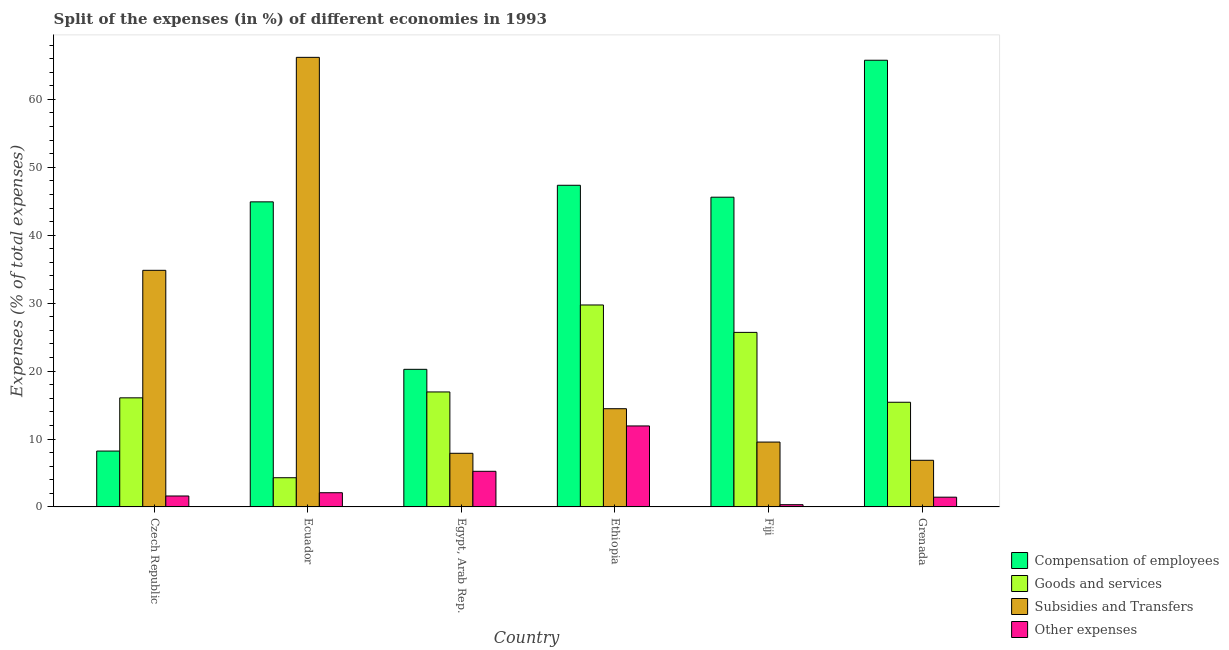How many different coloured bars are there?
Give a very brief answer. 4. Are the number of bars per tick equal to the number of legend labels?
Give a very brief answer. Yes. How many bars are there on the 3rd tick from the left?
Offer a very short reply. 4. How many bars are there on the 4th tick from the right?
Provide a short and direct response. 4. What is the label of the 4th group of bars from the left?
Your response must be concise. Ethiopia. In how many cases, is the number of bars for a given country not equal to the number of legend labels?
Offer a very short reply. 0. What is the percentage of amount spent on other expenses in Ethiopia?
Your answer should be very brief. 11.92. Across all countries, what is the maximum percentage of amount spent on compensation of employees?
Make the answer very short. 65.76. Across all countries, what is the minimum percentage of amount spent on other expenses?
Provide a short and direct response. 0.33. In which country was the percentage of amount spent on subsidies maximum?
Provide a succinct answer. Ecuador. In which country was the percentage of amount spent on compensation of employees minimum?
Provide a short and direct response. Czech Republic. What is the total percentage of amount spent on subsidies in the graph?
Your answer should be compact. 139.8. What is the difference between the percentage of amount spent on goods and services in Czech Republic and that in Ethiopia?
Give a very brief answer. -13.67. What is the difference between the percentage of amount spent on subsidies in Fiji and the percentage of amount spent on goods and services in Grenada?
Offer a terse response. -5.86. What is the average percentage of amount spent on other expenses per country?
Your answer should be compact. 3.77. What is the difference between the percentage of amount spent on other expenses and percentage of amount spent on subsidies in Ecuador?
Your answer should be compact. -64.1. What is the ratio of the percentage of amount spent on subsidies in Ecuador to that in Ethiopia?
Your response must be concise. 4.58. Is the percentage of amount spent on compensation of employees in Ecuador less than that in Ethiopia?
Ensure brevity in your answer.  Yes. Is the difference between the percentage of amount spent on other expenses in Ecuador and Grenada greater than the difference between the percentage of amount spent on subsidies in Ecuador and Grenada?
Give a very brief answer. No. What is the difference between the highest and the second highest percentage of amount spent on compensation of employees?
Provide a short and direct response. 18.41. What is the difference between the highest and the lowest percentage of amount spent on subsidies?
Offer a very short reply. 59.32. In how many countries, is the percentage of amount spent on goods and services greater than the average percentage of amount spent on goods and services taken over all countries?
Your response must be concise. 2. Is the sum of the percentage of amount spent on compensation of employees in Ecuador and Egypt, Arab Rep. greater than the maximum percentage of amount spent on subsidies across all countries?
Keep it short and to the point. No. Is it the case that in every country, the sum of the percentage of amount spent on compensation of employees and percentage of amount spent on other expenses is greater than the sum of percentage of amount spent on goods and services and percentage of amount spent on subsidies?
Your response must be concise. No. What does the 2nd bar from the left in Ethiopia represents?
Make the answer very short. Goods and services. What does the 1st bar from the right in Grenada represents?
Offer a very short reply. Other expenses. Are all the bars in the graph horizontal?
Your response must be concise. No. What is the difference between two consecutive major ticks on the Y-axis?
Give a very brief answer. 10. Does the graph contain any zero values?
Offer a very short reply. No. Does the graph contain grids?
Your answer should be very brief. No. What is the title of the graph?
Provide a short and direct response. Split of the expenses (in %) of different economies in 1993. Does "Ease of arranging shipments" appear as one of the legend labels in the graph?
Offer a terse response. No. What is the label or title of the X-axis?
Offer a terse response. Country. What is the label or title of the Y-axis?
Keep it short and to the point. Expenses (% of total expenses). What is the Expenses (% of total expenses) in Compensation of employees in Czech Republic?
Make the answer very short. 8.23. What is the Expenses (% of total expenses) in Goods and services in Czech Republic?
Make the answer very short. 16.06. What is the Expenses (% of total expenses) of Subsidies and Transfers in Czech Republic?
Give a very brief answer. 34.84. What is the Expenses (% of total expenses) of Other expenses in Czech Republic?
Your answer should be compact. 1.61. What is the Expenses (% of total expenses) of Compensation of employees in Ecuador?
Give a very brief answer. 44.92. What is the Expenses (% of total expenses) in Goods and services in Ecuador?
Your response must be concise. 4.3. What is the Expenses (% of total expenses) of Subsidies and Transfers in Ecuador?
Give a very brief answer. 66.19. What is the Expenses (% of total expenses) in Other expenses in Ecuador?
Give a very brief answer. 2.09. What is the Expenses (% of total expenses) in Compensation of employees in Egypt, Arab Rep.?
Offer a very short reply. 20.26. What is the Expenses (% of total expenses) in Goods and services in Egypt, Arab Rep.?
Your answer should be compact. 16.93. What is the Expenses (% of total expenses) of Subsidies and Transfers in Egypt, Arab Rep.?
Offer a very short reply. 7.9. What is the Expenses (% of total expenses) in Other expenses in Egypt, Arab Rep.?
Make the answer very short. 5.24. What is the Expenses (% of total expenses) in Compensation of employees in Ethiopia?
Your answer should be very brief. 47.36. What is the Expenses (% of total expenses) in Goods and services in Ethiopia?
Keep it short and to the point. 29.73. What is the Expenses (% of total expenses) in Subsidies and Transfers in Ethiopia?
Your answer should be compact. 14.46. What is the Expenses (% of total expenses) of Other expenses in Ethiopia?
Ensure brevity in your answer.  11.92. What is the Expenses (% of total expenses) in Compensation of employees in Fiji?
Offer a terse response. 45.6. What is the Expenses (% of total expenses) of Goods and services in Fiji?
Make the answer very short. 25.7. What is the Expenses (% of total expenses) of Subsidies and Transfers in Fiji?
Provide a succinct answer. 9.55. What is the Expenses (% of total expenses) of Other expenses in Fiji?
Your answer should be compact. 0.33. What is the Expenses (% of total expenses) in Compensation of employees in Grenada?
Provide a succinct answer. 65.76. What is the Expenses (% of total expenses) of Goods and services in Grenada?
Offer a very short reply. 15.41. What is the Expenses (% of total expenses) of Subsidies and Transfers in Grenada?
Provide a short and direct response. 6.87. What is the Expenses (% of total expenses) of Other expenses in Grenada?
Provide a short and direct response. 1.43. Across all countries, what is the maximum Expenses (% of total expenses) in Compensation of employees?
Keep it short and to the point. 65.76. Across all countries, what is the maximum Expenses (% of total expenses) of Goods and services?
Your answer should be very brief. 29.73. Across all countries, what is the maximum Expenses (% of total expenses) in Subsidies and Transfers?
Provide a succinct answer. 66.19. Across all countries, what is the maximum Expenses (% of total expenses) in Other expenses?
Give a very brief answer. 11.92. Across all countries, what is the minimum Expenses (% of total expenses) of Compensation of employees?
Provide a succinct answer. 8.23. Across all countries, what is the minimum Expenses (% of total expenses) in Goods and services?
Your answer should be compact. 4.3. Across all countries, what is the minimum Expenses (% of total expenses) in Subsidies and Transfers?
Ensure brevity in your answer.  6.87. Across all countries, what is the minimum Expenses (% of total expenses) of Other expenses?
Make the answer very short. 0.33. What is the total Expenses (% of total expenses) of Compensation of employees in the graph?
Ensure brevity in your answer.  232.13. What is the total Expenses (% of total expenses) of Goods and services in the graph?
Your answer should be very brief. 108.13. What is the total Expenses (% of total expenses) of Subsidies and Transfers in the graph?
Provide a short and direct response. 139.8. What is the total Expenses (% of total expenses) in Other expenses in the graph?
Provide a short and direct response. 22.63. What is the difference between the Expenses (% of total expenses) in Compensation of employees in Czech Republic and that in Ecuador?
Offer a very short reply. -36.69. What is the difference between the Expenses (% of total expenses) of Goods and services in Czech Republic and that in Ecuador?
Provide a short and direct response. 11.76. What is the difference between the Expenses (% of total expenses) of Subsidies and Transfers in Czech Republic and that in Ecuador?
Provide a short and direct response. -31.36. What is the difference between the Expenses (% of total expenses) in Other expenses in Czech Republic and that in Ecuador?
Provide a short and direct response. -0.48. What is the difference between the Expenses (% of total expenses) of Compensation of employees in Czech Republic and that in Egypt, Arab Rep.?
Make the answer very short. -12.03. What is the difference between the Expenses (% of total expenses) in Goods and services in Czech Republic and that in Egypt, Arab Rep.?
Your answer should be compact. -0.87. What is the difference between the Expenses (% of total expenses) of Subsidies and Transfers in Czech Republic and that in Egypt, Arab Rep.?
Provide a short and direct response. 26.94. What is the difference between the Expenses (% of total expenses) of Other expenses in Czech Republic and that in Egypt, Arab Rep.?
Ensure brevity in your answer.  -3.63. What is the difference between the Expenses (% of total expenses) of Compensation of employees in Czech Republic and that in Ethiopia?
Your response must be concise. -39.13. What is the difference between the Expenses (% of total expenses) in Goods and services in Czech Republic and that in Ethiopia?
Provide a succinct answer. -13.67. What is the difference between the Expenses (% of total expenses) of Subsidies and Transfers in Czech Republic and that in Ethiopia?
Provide a short and direct response. 20.37. What is the difference between the Expenses (% of total expenses) of Other expenses in Czech Republic and that in Ethiopia?
Your response must be concise. -10.31. What is the difference between the Expenses (% of total expenses) in Compensation of employees in Czech Republic and that in Fiji?
Give a very brief answer. -37.38. What is the difference between the Expenses (% of total expenses) in Goods and services in Czech Republic and that in Fiji?
Offer a terse response. -9.64. What is the difference between the Expenses (% of total expenses) of Subsidies and Transfers in Czech Republic and that in Fiji?
Offer a very short reply. 25.29. What is the difference between the Expenses (% of total expenses) of Other expenses in Czech Republic and that in Fiji?
Offer a terse response. 1.28. What is the difference between the Expenses (% of total expenses) in Compensation of employees in Czech Republic and that in Grenada?
Offer a very short reply. -57.54. What is the difference between the Expenses (% of total expenses) of Goods and services in Czech Republic and that in Grenada?
Make the answer very short. 0.65. What is the difference between the Expenses (% of total expenses) of Subsidies and Transfers in Czech Republic and that in Grenada?
Offer a terse response. 27.97. What is the difference between the Expenses (% of total expenses) in Other expenses in Czech Republic and that in Grenada?
Offer a very short reply. 0.18. What is the difference between the Expenses (% of total expenses) of Compensation of employees in Ecuador and that in Egypt, Arab Rep.?
Ensure brevity in your answer.  24.66. What is the difference between the Expenses (% of total expenses) in Goods and services in Ecuador and that in Egypt, Arab Rep.?
Provide a succinct answer. -12.63. What is the difference between the Expenses (% of total expenses) in Subsidies and Transfers in Ecuador and that in Egypt, Arab Rep.?
Your answer should be compact. 58.29. What is the difference between the Expenses (% of total expenses) of Other expenses in Ecuador and that in Egypt, Arab Rep.?
Offer a very short reply. -3.15. What is the difference between the Expenses (% of total expenses) of Compensation of employees in Ecuador and that in Ethiopia?
Your answer should be compact. -2.44. What is the difference between the Expenses (% of total expenses) in Goods and services in Ecuador and that in Ethiopia?
Ensure brevity in your answer.  -25.43. What is the difference between the Expenses (% of total expenses) of Subsidies and Transfers in Ecuador and that in Ethiopia?
Give a very brief answer. 51.73. What is the difference between the Expenses (% of total expenses) in Other expenses in Ecuador and that in Ethiopia?
Give a very brief answer. -9.83. What is the difference between the Expenses (% of total expenses) in Compensation of employees in Ecuador and that in Fiji?
Your answer should be very brief. -0.69. What is the difference between the Expenses (% of total expenses) in Goods and services in Ecuador and that in Fiji?
Your answer should be very brief. -21.4. What is the difference between the Expenses (% of total expenses) of Subsidies and Transfers in Ecuador and that in Fiji?
Ensure brevity in your answer.  56.64. What is the difference between the Expenses (% of total expenses) of Other expenses in Ecuador and that in Fiji?
Keep it short and to the point. 1.76. What is the difference between the Expenses (% of total expenses) in Compensation of employees in Ecuador and that in Grenada?
Your response must be concise. -20.85. What is the difference between the Expenses (% of total expenses) of Goods and services in Ecuador and that in Grenada?
Offer a terse response. -11.11. What is the difference between the Expenses (% of total expenses) of Subsidies and Transfers in Ecuador and that in Grenada?
Your answer should be very brief. 59.32. What is the difference between the Expenses (% of total expenses) of Other expenses in Ecuador and that in Grenada?
Your answer should be compact. 0.66. What is the difference between the Expenses (% of total expenses) of Compensation of employees in Egypt, Arab Rep. and that in Ethiopia?
Provide a short and direct response. -27.1. What is the difference between the Expenses (% of total expenses) in Goods and services in Egypt, Arab Rep. and that in Ethiopia?
Ensure brevity in your answer.  -12.8. What is the difference between the Expenses (% of total expenses) of Subsidies and Transfers in Egypt, Arab Rep. and that in Ethiopia?
Your answer should be compact. -6.56. What is the difference between the Expenses (% of total expenses) of Other expenses in Egypt, Arab Rep. and that in Ethiopia?
Provide a short and direct response. -6.68. What is the difference between the Expenses (% of total expenses) of Compensation of employees in Egypt, Arab Rep. and that in Fiji?
Ensure brevity in your answer.  -25.34. What is the difference between the Expenses (% of total expenses) in Goods and services in Egypt, Arab Rep. and that in Fiji?
Offer a terse response. -8.77. What is the difference between the Expenses (% of total expenses) in Subsidies and Transfers in Egypt, Arab Rep. and that in Fiji?
Ensure brevity in your answer.  -1.65. What is the difference between the Expenses (% of total expenses) in Other expenses in Egypt, Arab Rep. and that in Fiji?
Give a very brief answer. 4.92. What is the difference between the Expenses (% of total expenses) in Compensation of employees in Egypt, Arab Rep. and that in Grenada?
Keep it short and to the point. -45.5. What is the difference between the Expenses (% of total expenses) of Goods and services in Egypt, Arab Rep. and that in Grenada?
Make the answer very short. 1.52. What is the difference between the Expenses (% of total expenses) of Subsidies and Transfers in Egypt, Arab Rep. and that in Grenada?
Your response must be concise. 1.03. What is the difference between the Expenses (% of total expenses) of Other expenses in Egypt, Arab Rep. and that in Grenada?
Offer a very short reply. 3.81. What is the difference between the Expenses (% of total expenses) of Compensation of employees in Ethiopia and that in Fiji?
Your answer should be compact. 1.76. What is the difference between the Expenses (% of total expenses) of Goods and services in Ethiopia and that in Fiji?
Offer a very short reply. 4.04. What is the difference between the Expenses (% of total expenses) of Subsidies and Transfers in Ethiopia and that in Fiji?
Offer a terse response. 4.91. What is the difference between the Expenses (% of total expenses) in Other expenses in Ethiopia and that in Fiji?
Your answer should be very brief. 11.59. What is the difference between the Expenses (% of total expenses) of Compensation of employees in Ethiopia and that in Grenada?
Provide a succinct answer. -18.41. What is the difference between the Expenses (% of total expenses) in Goods and services in Ethiopia and that in Grenada?
Your response must be concise. 14.32. What is the difference between the Expenses (% of total expenses) of Subsidies and Transfers in Ethiopia and that in Grenada?
Make the answer very short. 7.6. What is the difference between the Expenses (% of total expenses) of Other expenses in Ethiopia and that in Grenada?
Provide a succinct answer. 10.49. What is the difference between the Expenses (% of total expenses) of Compensation of employees in Fiji and that in Grenada?
Offer a very short reply. -20.16. What is the difference between the Expenses (% of total expenses) in Goods and services in Fiji and that in Grenada?
Offer a very short reply. 10.29. What is the difference between the Expenses (% of total expenses) in Subsidies and Transfers in Fiji and that in Grenada?
Offer a very short reply. 2.68. What is the difference between the Expenses (% of total expenses) in Other expenses in Fiji and that in Grenada?
Give a very brief answer. -1.11. What is the difference between the Expenses (% of total expenses) of Compensation of employees in Czech Republic and the Expenses (% of total expenses) of Goods and services in Ecuador?
Provide a succinct answer. 3.93. What is the difference between the Expenses (% of total expenses) in Compensation of employees in Czech Republic and the Expenses (% of total expenses) in Subsidies and Transfers in Ecuador?
Your answer should be very brief. -57.96. What is the difference between the Expenses (% of total expenses) in Compensation of employees in Czech Republic and the Expenses (% of total expenses) in Other expenses in Ecuador?
Make the answer very short. 6.14. What is the difference between the Expenses (% of total expenses) in Goods and services in Czech Republic and the Expenses (% of total expenses) in Subsidies and Transfers in Ecuador?
Your response must be concise. -50.13. What is the difference between the Expenses (% of total expenses) of Goods and services in Czech Republic and the Expenses (% of total expenses) of Other expenses in Ecuador?
Your answer should be very brief. 13.97. What is the difference between the Expenses (% of total expenses) of Subsidies and Transfers in Czech Republic and the Expenses (% of total expenses) of Other expenses in Ecuador?
Give a very brief answer. 32.74. What is the difference between the Expenses (% of total expenses) of Compensation of employees in Czech Republic and the Expenses (% of total expenses) of Goods and services in Egypt, Arab Rep.?
Your response must be concise. -8.7. What is the difference between the Expenses (% of total expenses) in Compensation of employees in Czech Republic and the Expenses (% of total expenses) in Subsidies and Transfers in Egypt, Arab Rep.?
Keep it short and to the point. 0.33. What is the difference between the Expenses (% of total expenses) of Compensation of employees in Czech Republic and the Expenses (% of total expenses) of Other expenses in Egypt, Arab Rep.?
Your answer should be compact. 2.98. What is the difference between the Expenses (% of total expenses) in Goods and services in Czech Republic and the Expenses (% of total expenses) in Subsidies and Transfers in Egypt, Arab Rep.?
Ensure brevity in your answer.  8.16. What is the difference between the Expenses (% of total expenses) in Goods and services in Czech Republic and the Expenses (% of total expenses) in Other expenses in Egypt, Arab Rep.?
Keep it short and to the point. 10.82. What is the difference between the Expenses (% of total expenses) of Subsidies and Transfers in Czech Republic and the Expenses (% of total expenses) of Other expenses in Egypt, Arab Rep.?
Keep it short and to the point. 29.59. What is the difference between the Expenses (% of total expenses) in Compensation of employees in Czech Republic and the Expenses (% of total expenses) in Goods and services in Ethiopia?
Your answer should be compact. -21.51. What is the difference between the Expenses (% of total expenses) in Compensation of employees in Czech Republic and the Expenses (% of total expenses) in Subsidies and Transfers in Ethiopia?
Your response must be concise. -6.23. What is the difference between the Expenses (% of total expenses) in Compensation of employees in Czech Republic and the Expenses (% of total expenses) in Other expenses in Ethiopia?
Offer a terse response. -3.7. What is the difference between the Expenses (% of total expenses) in Goods and services in Czech Republic and the Expenses (% of total expenses) in Subsidies and Transfers in Ethiopia?
Ensure brevity in your answer.  1.6. What is the difference between the Expenses (% of total expenses) in Goods and services in Czech Republic and the Expenses (% of total expenses) in Other expenses in Ethiopia?
Provide a short and direct response. 4.14. What is the difference between the Expenses (% of total expenses) in Subsidies and Transfers in Czech Republic and the Expenses (% of total expenses) in Other expenses in Ethiopia?
Provide a short and direct response. 22.91. What is the difference between the Expenses (% of total expenses) in Compensation of employees in Czech Republic and the Expenses (% of total expenses) in Goods and services in Fiji?
Your answer should be compact. -17.47. What is the difference between the Expenses (% of total expenses) of Compensation of employees in Czech Republic and the Expenses (% of total expenses) of Subsidies and Transfers in Fiji?
Provide a succinct answer. -1.32. What is the difference between the Expenses (% of total expenses) of Compensation of employees in Czech Republic and the Expenses (% of total expenses) of Other expenses in Fiji?
Give a very brief answer. 7.9. What is the difference between the Expenses (% of total expenses) in Goods and services in Czech Republic and the Expenses (% of total expenses) in Subsidies and Transfers in Fiji?
Keep it short and to the point. 6.51. What is the difference between the Expenses (% of total expenses) in Goods and services in Czech Republic and the Expenses (% of total expenses) in Other expenses in Fiji?
Provide a short and direct response. 15.73. What is the difference between the Expenses (% of total expenses) of Subsidies and Transfers in Czech Republic and the Expenses (% of total expenses) of Other expenses in Fiji?
Offer a very short reply. 34.51. What is the difference between the Expenses (% of total expenses) in Compensation of employees in Czech Republic and the Expenses (% of total expenses) in Goods and services in Grenada?
Keep it short and to the point. -7.18. What is the difference between the Expenses (% of total expenses) of Compensation of employees in Czech Republic and the Expenses (% of total expenses) of Subsidies and Transfers in Grenada?
Your response must be concise. 1.36. What is the difference between the Expenses (% of total expenses) in Compensation of employees in Czech Republic and the Expenses (% of total expenses) in Other expenses in Grenada?
Keep it short and to the point. 6.79. What is the difference between the Expenses (% of total expenses) of Goods and services in Czech Republic and the Expenses (% of total expenses) of Subsidies and Transfers in Grenada?
Your answer should be compact. 9.2. What is the difference between the Expenses (% of total expenses) in Goods and services in Czech Republic and the Expenses (% of total expenses) in Other expenses in Grenada?
Ensure brevity in your answer.  14.63. What is the difference between the Expenses (% of total expenses) in Subsidies and Transfers in Czech Republic and the Expenses (% of total expenses) in Other expenses in Grenada?
Give a very brief answer. 33.4. What is the difference between the Expenses (% of total expenses) of Compensation of employees in Ecuador and the Expenses (% of total expenses) of Goods and services in Egypt, Arab Rep.?
Your answer should be very brief. 27.99. What is the difference between the Expenses (% of total expenses) in Compensation of employees in Ecuador and the Expenses (% of total expenses) in Subsidies and Transfers in Egypt, Arab Rep.?
Provide a short and direct response. 37.02. What is the difference between the Expenses (% of total expenses) of Compensation of employees in Ecuador and the Expenses (% of total expenses) of Other expenses in Egypt, Arab Rep.?
Give a very brief answer. 39.67. What is the difference between the Expenses (% of total expenses) in Goods and services in Ecuador and the Expenses (% of total expenses) in Subsidies and Transfers in Egypt, Arab Rep.?
Your answer should be very brief. -3.6. What is the difference between the Expenses (% of total expenses) of Goods and services in Ecuador and the Expenses (% of total expenses) of Other expenses in Egypt, Arab Rep.?
Keep it short and to the point. -0.94. What is the difference between the Expenses (% of total expenses) of Subsidies and Transfers in Ecuador and the Expenses (% of total expenses) of Other expenses in Egypt, Arab Rep.?
Your answer should be very brief. 60.95. What is the difference between the Expenses (% of total expenses) in Compensation of employees in Ecuador and the Expenses (% of total expenses) in Goods and services in Ethiopia?
Offer a terse response. 15.18. What is the difference between the Expenses (% of total expenses) of Compensation of employees in Ecuador and the Expenses (% of total expenses) of Subsidies and Transfers in Ethiopia?
Provide a succinct answer. 30.45. What is the difference between the Expenses (% of total expenses) in Compensation of employees in Ecuador and the Expenses (% of total expenses) in Other expenses in Ethiopia?
Offer a very short reply. 32.99. What is the difference between the Expenses (% of total expenses) in Goods and services in Ecuador and the Expenses (% of total expenses) in Subsidies and Transfers in Ethiopia?
Make the answer very short. -10.16. What is the difference between the Expenses (% of total expenses) of Goods and services in Ecuador and the Expenses (% of total expenses) of Other expenses in Ethiopia?
Give a very brief answer. -7.62. What is the difference between the Expenses (% of total expenses) of Subsidies and Transfers in Ecuador and the Expenses (% of total expenses) of Other expenses in Ethiopia?
Your response must be concise. 54.27. What is the difference between the Expenses (% of total expenses) of Compensation of employees in Ecuador and the Expenses (% of total expenses) of Goods and services in Fiji?
Make the answer very short. 19.22. What is the difference between the Expenses (% of total expenses) of Compensation of employees in Ecuador and the Expenses (% of total expenses) of Subsidies and Transfers in Fiji?
Your answer should be compact. 35.37. What is the difference between the Expenses (% of total expenses) of Compensation of employees in Ecuador and the Expenses (% of total expenses) of Other expenses in Fiji?
Offer a terse response. 44.59. What is the difference between the Expenses (% of total expenses) in Goods and services in Ecuador and the Expenses (% of total expenses) in Subsidies and Transfers in Fiji?
Provide a short and direct response. -5.25. What is the difference between the Expenses (% of total expenses) of Goods and services in Ecuador and the Expenses (% of total expenses) of Other expenses in Fiji?
Offer a very short reply. 3.97. What is the difference between the Expenses (% of total expenses) in Subsidies and Transfers in Ecuador and the Expenses (% of total expenses) in Other expenses in Fiji?
Offer a very short reply. 65.86. What is the difference between the Expenses (% of total expenses) of Compensation of employees in Ecuador and the Expenses (% of total expenses) of Goods and services in Grenada?
Your answer should be compact. 29.51. What is the difference between the Expenses (% of total expenses) in Compensation of employees in Ecuador and the Expenses (% of total expenses) in Subsidies and Transfers in Grenada?
Provide a succinct answer. 38.05. What is the difference between the Expenses (% of total expenses) in Compensation of employees in Ecuador and the Expenses (% of total expenses) in Other expenses in Grenada?
Your answer should be very brief. 43.48. What is the difference between the Expenses (% of total expenses) of Goods and services in Ecuador and the Expenses (% of total expenses) of Subsidies and Transfers in Grenada?
Offer a terse response. -2.57. What is the difference between the Expenses (% of total expenses) in Goods and services in Ecuador and the Expenses (% of total expenses) in Other expenses in Grenada?
Ensure brevity in your answer.  2.86. What is the difference between the Expenses (% of total expenses) in Subsidies and Transfers in Ecuador and the Expenses (% of total expenses) in Other expenses in Grenada?
Your answer should be compact. 64.76. What is the difference between the Expenses (% of total expenses) of Compensation of employees in Egypt, Arab Rep. and the Expenses (% of total expenses) of Goods and services in Ethiopia?
Make the answer very short. -9.47. What is the difference between the Expenses (% of total expenses) in Compensation of employees in Egypt, Arab Rep. and the Expenses (% of total expenses) in Subsidies and Transfers in Ethiopia?
Offer a terse response. 5.8. What is the difference between the Expenses (% of total expenses) in Compensation of employees in Egypt, Arab Rep. and the Expenses (% of total expenses) in Other expenses in Ethiopia?
Your answer should be compact. 8.34. What is the difference between the Expenses (% of total expenses) in Goods and services in Egypt, Arab Rep. and the Expenses (% of total expenses) in Subsidies and Transfers in Ethiopia?
Ensure brevity in your answer.  2.47. What is the difference between the Expenses (% of total expenses) of Goods and services in Egypt, Arab Rep. and the Expenses (% of total expenses) of Other expenses in Ethiopia?
Your answer should be compact. 5.01. What is the difference between the Expenses (% of total expenses) in Subsidies and Transfers in Egypt, Arab Rep. and the Expenses (% of total expenses) in Other expenses in Ethiopia?
Your response must be concise. -4.03. What is the difference between the Expenses (% of total expenses) in Compensation of employees in Egypt, Arab Rep. and the Expenses (% of total expenses) in Goods and services in Fiji?
Offer a terse response. -5.44. What is the difference between the Expenses (% of total expenses) of Compensation of employees in Egypt, Arab Rep. and the Expenses (% of total expenses) of Subsidies and Transfers in Fiji?
Your response must be concise. 10.71. What is the difference between the Expenses (% of total expenses) of Compensation of employees in Egypt, Arab Rep. and the Expenses (% of total expenses) of Other expenses in Fiji?
Ensure brevity in your answer.  19.93. What is the difference between the Expenses (% of total expenses) in Goods and services in Egypt, Arab Rep. and the Expenses (% of total expenses) in Subsidies and Transfers in Fiji?
Your answer should be compact. 7.38. What is the difference between the Expenses (% of total expenses) of Goods and services in Egypt, Arab Rep. and the Expenses (% of total expenses) of Other expenses in Fiji?
Your response must be concise. 16.6. What is the difference between the Expenses (% of total expenses) in Subsidies and Transfers in Egypt, Arab Rep. and the Expenses (% of total expenses) in Other expenses in Fiji?
Your answer should be compact. 7.57. What is the difference between the Expenses (% of total expenses) of Compensation of employees in Egypt, Arab Rep. and the Expenses (% of total expenses) of Goods and services in Grenada?
Offer a very short reply. 4.85. What is the difference between the Expenses (% of total expenses) in Compensation of employees in Egypt, Arab Rep. and the Expenses (% of total expenses) in Subsidies and Transfers in Grenada?
Offer a very short reply. 13.39. What is the difference between the Expenses (% of total expenses) in Compensation of employees in Egypt, Arab Rep. and the Expenses (% of total expenses) in Other expenses in Grenada?
Give a very brief answer. 18.83. What is the difference between the Expenses (% of total expenses) in Goods and services in Egypt, Arab Rep. and the Expenses (% of total expenses) in Subsidies and Transfers in Grenada?
Offer a terse response. 10.06. What is the difference between the Expenses (% of total expenses) of Goods and services in Egypt, Arab Rep. and the Expenses (% of total expenses) of Other expenses in Grenada?
Keep it short and to the point. 15.49. What is the difference between the Expenses (% of total expenses) of Subsidies and Transfers in Egypt, Arab Rep. and the Expenses (% of total expenses) of Other expenses in Grenada?
Offer a terse response. 6.46. What is the difference between the Expenses (% of total expenses) in Compensation of employees in Ethiopia and the Expenses (% of total expenses) in Goods and services in Fiji?
Your answer should be very brief. 21.66. What is the difference between the Expenses (% of total expenses) of Compensation of employees in Ethiopia and the Expenses (% of total expenses) of Subsidies and Transfers in Fiji?
Make the answer very short. 37.81. What is the difference between the Expenses (% of total expenses) in Compensation of employees in Ethiopia and the Expenses (% of total expenses) in Other expenses in Fiji?
Provide a succinct answer. 47.03. What is the difference between the Expenses (% of total expenses) of Goods and services in Ethiopia and the Expenses (% of total expenses) of Subsidies and Transfers in Fiji?
Your answer should be compact. 20.18. What is the difference between the Expenses (% of total expenses) of Goods and services in Ethiopia and the Expenses (% of total expenses) of Other expenses in Fiji?
Offer a very short reply. 29.4. What is the difference between the Expenses (% of total expenses) of Subsidies and Transfers in Ethiopia and the Expenses (% of total expenses) of Other expenses in Fiji?
Your answer should be very brief. 14.13. What is the difference between the Expenses (% of total expenses) in Compensation of employees in Ethiopia and the Expenses (% of total expenses) in Goods and services in Grenada?
Make the answer very short. 31.95. What is the difference between the Expenses (% of total expenses) of Compensation of employees in Ethiopia and the Expenses (% of total expenses) of Subsidies and Transfers in Grenada?
Give a very brief answer. 40.49. What is the difference between the Expenses (% of total expenses) of Compensation of employees in Ethiopia and the Expenses (% of total expenses) of Other expenses in Grenada?
Keep it short and to the point. 45.92. What is the difference between the Expenses (% of total expenses) of Goods and services in Ethiopia and the Expenses (% of total expenses) of Subsidies and Transfers in Grenada?
Give a very brief answer. 22.87. What is the difference between the Expenses (% of total expenses) of Goods and services in Ethiopia and the Expenses (% of total expenses) of Other expenses in Grenada?
Make the answer very short. 28.3. What is the difference between the Expenses (% of total expenses) of Subsidies and Transfers in Ethiopia and the Expenses (% of total expenses) of Other expenses in Grenada?
Your answer should be very brief. 13.03. What is the difference between the Expenses (% of total expenses) in Compensation of employees in Fiji and the Expenses (% of total expenses) in Goods and services in Grenada?
Offer a very short reply. 30.19. What is the difference between the Expenses (% of total expenses) of Compensation of employees in Fiji and the Expenses (% of total expenses) of Subsidies and Transfers in Grenada?
Give a very brief answer. 38.74. What is the difference between the Expenses (% of total expenses) in Compensation of employees in Fiji and the Expenses (% of total expenses) in Other expenses in Grenada?
Make the answer very short. 44.17. What is the difference between the Expenses (% of total expenses) of Goods and services in Fiji and the Expenses (% of total expenses) of Subsidies and Transfers in Grenada?
Give a very brief answer. 18.83. What is the difference between the Expenses (% of total expenses) in Goods and services in Fiji and the Expenses (% of total expenses) in Other expenses in Grenada?
Your answer should be compact. 24.26. What is the difference between the Expenses (% of total expenses) in Subsidies and Transfers in Fiji and the Expenses (% of total expenses) in Other expenses in Grenada?
Your answer should be compact. 8.12. What is the average Expenses (% of total expenses) in Compensation of employees per country?
Ensure brevity in your answer.  38.69. What is the average Expenses (% of total expenses) in Goods and services per country?
Keep it short and to the point. 18.02. What is the average Expenses (% of total expenses) in Subsidies and Transfers per country?
Provide a succinct answer. 23.3. What is the average Expenses (% of total expenses) in Other expenses per country?
Offer a terse response. 3.77. What is the difference between the Expenses (% of total expenses) in Compensation of employees and Expenses (% of total expenses) in Goods and services in Czech Republic?
Offer a terse response. -7.83. What is the difference between the Expenses (% of total expenses) in Compensation of employees and Expenses (% of total expenses) in Subsidies and Transfers in Czech Republic?
Your response must be concise. -26.61. What is the difference between the Expenses (% of total expenses) in Compensation of employees and Expenses (% of total expenses) in Other expenses in Czech Republic?
Ensure brevity in your answer.  6.62. What is the difference between the Expenses (% of total expenses) of Goods and services and Expenses (% of total expenses) of Subsidies and Transfers in Czech Republic?
Your answer should be very brief. -18.77. What is the difference between the Expenses (% of total expenses) of Goods and services and Expenses (% of total expenses) of Other expenses in Czech Republic?
Offer a terse response. 14.45. What is the difference between the Expenses (% of total expenses) in Subsidies and Transfers and Expenses (% of total expenses) in Other expenses in Czech Republic?
Ensure brevity in your answer.  33.23. What is the difference between the Expenses (% of total expenses) of Compensation of employees and Expenses (% of total expenses) of Goods and services in Ecuador?
Ensure brevity in your answer.  40.62. What is the difference between the Expenses (% of total expenses) of Compensation of employees and Expenses (% of total expenses) of Subsidies and Transfers in Ecuador?
Make the answer very short. -21.27. What is the difference between the Expenses (% of total expenses) in Compensation of employees and Expenses (% of total expenses) in Other expenses in Ecuador?
Give a very brief answer. 42.82. What is the difference between the Expenses (% of total expenses) in Goods and services and Expenses (% of total expenses) in Subsidies and Transfers in Ecuador?
Ensure brevity in your answer.  -61.89. What is the difference between the Expenses (% of total expenses) in Goods and services and Expenses (% of total expenses) in Other expenses in Ecuador?
Provide a succinct answer. 2.21. What is the difference between the Expenses (% of total expenses) of Subsidies and Transfers and Expenses (% of total expenses) of Other expenses in Ecuador?
Provide a succinct answer. 64.1. What is the difference between the Expenses (% of total expenses) in Compensation of employees and Expenses (% of total expenses) in Goods and services in Egypt, Arab Rep.?
Provide a succinct answer. 3.33. What is the difference between the Expenses (% of total expenses) of Compensation of employees and Expenses (% of total expenses) of Subsidies and Transfers in Egypt, Arab Rep.?
Make the answer very short. 12.36. What is the difference between the Expenses (% of total expenses) of Compensation of employees and Expenses (% of total expenses) of Other expenses in Egypt, Arab Rep.?
Give a very brief answer. 15.02. What is the difference between the Expenses (% of total expenses) of Goods and services and Expenses (% of total expenses) of Subsidies and Transfers in Egypt, Arab Rep.?
Offer a very short reply. 9.03. What is the difference between the Expenses (% of total expenses) in Goods and services and Expenses (% of total expenses) in Other expenses in Egypt, Arab Rep.?
Offer a terse response. 11.68. What is the difference between the Expenses (% of total expenses) in Subsidies and Transfers and Expenses (% of total expenses) in Other expenses in Egypt, Arab Rep.?
Your answer should be very brief. 2.65. What is the difference between the Expenses (% of total expenses) in Compensation of employees and Expenses (% of total expenses) in Goods and services in Ethiopia?
Keep it short and to the point. 17.62. What is the difference between the Expenses (% of total expenses) in Compensation of employees and Expenses (% of total expenses) in Subsidies and Transfers in Ethiopia?
Your response must be concise. 32.9. What is the difference between the Expenses (% of total expenses) of Compensation of employees and Expenses (% of total expenses) of Other expenses in Ethiopia?
Give a very brief answer. 35.44. What is the difference between the Expenses (% of total expenses) in Goods and services and Expenses (% of total expenses) in Subsidies and Transfers in Ethiopia?
Provide a succinct answer. 15.27. What is the difference between the Expenses (% of total expenses) in Goods and services and Expenses (% of total expenses) in Other expenses in Ethiopia?
Give a very brief answer. 17.81. What is the difference between the Expenses (% of total expenses) in Subsidies and Transfers and Expenses (% of total expenses) in Other expenses in Ethiopia?
Your response must be concise. 2.54. What is the difference between the Expenses (% of total expenses) in Compensation of employees and Expenses (% of total expenses) in Goods and services in Fiji?
Keep it short and to the point. 19.9. What is the difference between the Expenses (% of total expenses) in Compensation of employees and Expenses (% of total expenses) in Subsidies and Transfers in Fiji?
Offer a very short reply. 36.05. What is the difference between the Expenses (% of total expenses) in Compensation of employees and Expenses (% of total expenses) in Other expenses in Fiji?
Your answer should be compact. 45.27. What is the difference between the Expenses (% of total expenses) of Goods and services and Expenses (% of total expenses) of Subsidies and Transfers in Fiji?
Offer a very short reply. 16.15. What is the difference between the Expenses (% of total expenses) of Goods and services and Expenses (% of total expenses) of Other expenses in Fiji?
Offer a terse response. 25.37. What is the difference between the Expenses (% of total expenses) of Subsidies and Transfers and Expenses (% of total expenses) of Other expenses in Fiji?
Ensure brevity in your answer.  9.22. What is the difference between the Expenses (% of total expenses) in Compensation of employees and Expenses (% of total expenses) in Goods and services in Grenada?
Make the answer very short. 50.35. What is the difference between the Expenses (% of total expenses) in Compensation of employees and Expenses (% of total expenses) in Subsidies and Transfers in Grenada?
Provide a short and direct response. 58.9. What is the difference between the Expenses (% of total expenses) in Compensation of employees and Expenses (% of total expenses) in Other expenses in Grenada?
Provide a succinct answer. 64.33. What is the difference between the Expenses (% of total expenses) of Goods and services and Expenses (% of total expenses) of Subsidies and Transfers in Grenada?
Your answer should be compact. 8.55. What is the difference between the Expenses (% of total expenses) in Goods and services and Expenses (% of total expenses) in Other expenses in Grenada?
Your answer should be compact. 13.98. What is the difference between the Expenses (% of total expenses) of Subsidies and Transfers and Expenses (% of total expenses) of Other expenses in Grenada?
Make the answer very short. 5.43. What is the ratio of the Expenses (% of total expenses) in Compensation of employees in Czech Republic to that in Ecuador?
Make the answer very short. 0.18. What is the ratio of the Expenses (% of total expenses) of Goods and services in Czech Republic to that in Ecuador?
Give a very brief answer. 3.74. What is the ratio of the Expenses (% of total expenses) in Subsidies and Transfers in Czech Republic to that in Ecuador?
Keep it short and to the point. 0.53. What is the ratio of the Expenses (% of total expenses) of Other expenses in Czech Republic to that in Ecuador?
Your answer should be compact. 0.77. What is the ratio of the Expenses (% of total expenses) of Compensation of employees in Czech Republic to that in Egypt, Arab Rep.?
Offer a very short reply. 0.41. What is the ratio of the Expenses (% of total expenses) in Goods and services in Czech Republic to that in Egypt, Arab Rep.?
Your response must be concise. 0.95. What is the ratio of the Expenses (% of total expenses) of Subsidies and Transfers in Czech Republic to that in Egypt, Arab Rep.?
Offer a very short reply. 4.41. What is the ratio of the Expenses (% of total expenses) of Other expenses in Czech Republic to that in Egypt, Arab Rep.?
Offer a terse response. 0.31. What is the ratio of the Expenses (% of total expenses) of Compensation of employees in Czech Republic to that in Ethiopia?
Offer a very short reply. 0.17. What is the ratio of the Expenses (% of total expenses) of Goods and services in Czech Republic to that in Ethiopia?
Offer a terse response. 0.54. What is the ratio of the Expenses (% of total expenses) of Subsidies and Transfers in Czech Republic to that in Ethiopia?
Your response must be concise. 2.41. What is the ratio of the Expenses (% of total expenses) of Other expenses in Czech Republic to that in Ethiopia?
Provide a succinct answer. 0.14. What is the ratio of the Expenses (% of total expenses) in Compensation of employees in Czech Republic to that in Fiji?
Your answer should be very brief. 0.18. What is the ratio of the Expenses (% of total expenses) in Goods and services in Czech Republic to that in Fiji?
Provide a short and direct response. 0.62. What is the ratio of the Expenses (% of total expenses) in Subsidies and Transfers in Czech Republic to that in Fiji?
Provide a succinct answer. 3.65. What is the ratio of the Expenses (% of total expenses) in Other expenses in Czech Republic to that in Fiji?
Keep it short and to the point. 4.9. What is the ratio of the Expenses (% of total expenses) in Compensation of employees in Czech Republic to that in Grenada?
Offer a terse response. 0.13. What is the ratio of the Expenses (% of total expenses) in Goods and services in Czech Republic to that in Grenada?
Offer a terse response. 1.04. What is the ratio of the Expenses (% of total expenses) of Subsidies and Transfers in Czech Republic to that in Grenada?
Make the answer very short. 5.07. What is the ratio of the Expenses (% of total expenses) of Other expenses in Czech Republic to that in Grenada?
Ensure brevity in your answer.  1.12. What is the ratio of the Expenses (% of total expenses) in Compensation of employees in Ecuador to that in Egypt, Arab Rep.?
Ensure brevity in your answer.  2.22. What is the ratio of the Expenses (% of total expenses) in Goods and services in Ecuador to that in Egypt, Arab Rep.?
Keep it short and to the point. 0.25. What is the ratio of the Expenses (% of total expenses) of Subsidies and Transfers in Ecuador to that in Egypt, Arab Rep.?
Provide a short and direct response. 8.38. What is the ratio of the Expenses (% of total expenses) of Other expenses in Ecuador to that in Egypt, Arab Rep.?
Provide a short and direct response. 0.4. What is the ratio of the Expenses (% of total expenses) in Compensation of employees in Ecuador to that in Ethiopia?
Give a very brief answer. 0.95. What is the ratio of the Expenses (% of total expenses) of Goods and services in Ecuador to that in Ethiopia?
Your response must be concise. 0.14. What is the ratio of the Expenses (% of total expenses) in Subsidies and Transfers in Ecuador to that in Ethiopia?
Your answer should be compact. 4.58. What is the ratio of the Expenses (% of total expenses) in Other expenses in Ecuador to that in Ethiopia?
Make the answer very short. 0.18. What is the ratio of the Expenses (% of total expenses) in Goods and services in Ecuador to that in Fiji?
Keep it short and to the point. 0.17. What is the ratio of the Expenses (% of total expenses) of Subsidies and Transfers in Ecuador to that in Fiji?
Provide a short and direct response. 6.93. What is the ratio of the Expenses (% of total expenses) in Other expenses in Ecuador to that in Fiji?
Your response must be concise. 6.36. What is the ratio of the Expenses (% of total expenses) of Compensation of employees in Ecuador to that in Grenada?
Offer a very short reply. 0.68. What is the ratio of the Expenses (% of total expenses) of Goods and services in Ecuador to that in Grenada?
Keep it short and to the point. 0.28. What is the ratio of the Expenses (% of total expenses) of Subsidies and Transfers in Ecuador to that in Grenada?
Keep it short and to the point. 9.64. What is the ratio of the Expenses (% of total expenses) of Other expenses in Ecuador to that in Grenada?
Your response must be concise. 1.46. What is the ratio of the Expenses (% of total expenses) in Compensation of employees in Egypt, Arab Rep. to that in Ethiopia?
Provide a short and direct response. 0.43. What is the ratio of the Expenses (% of total expenses) of Goods and services in Egypt, Arab Rep. to that in Ethiopia?
Your answer should be very brief. 0.57. What is the ratio of the Expenses (% of total expenses) of Subsidies and Transfers in Egypt, Arab Rep. to that in Ethiopia?
Keep it short and to the point. 0.55. What is the ratio of the Expenses (% of total expenses) of Other expenses in Egypt, Arab Rep. to that in Ethiopia?
Offer a terse response. 0.44. What is the ratio of the Expenses (% of total expenses) in Compensation of employees in Egypt, Arab Rep. to that in Fiji?
Offer a terse response. 0.44. What is the ratio of the Expenses (% of total expenses) in Goods and services in Egypt, Arab Rep. to that in Fiji?
Make the answer very short. 0.66. What is the ratio of the Expenses (% of total expenses) in Subsidies and Transfers in Egypt, Arab Rep. to that in Fiji?
Provide a succinct answer. 0.83. What is the ratio of the Expenses (% of total expenses) in Other expenses in Egypt, Arab Rep. to that in Fiji?
Your answer should be very brief. 15.95. What is the ratio of the Expenses (% of total expenses) of Compensation of employees in Egypt, Arab Rep. to that in Grenada?
Offer a terse response. 0.31. What is the ratio of the Expenses (% of total expenses) in Goods and services in Egypt, Arab Rep. to that in Grenada?
Your answer should be compact. 1.1. What is the ratio of the Expenses (% of total expenses) in Subsidies and Transfers in Egypt, Arab Rep. to that in Grenada?
Keep it short and to the point. 1.15. What is the ratio of the Expenses (% of total expenses) in Other expenses in Egypt, Arab Rep. to that in Grenada?
Provide a short and direct response. 3.66. What is the ratio of the Expenses (% of total expenses) of Goods and services in Ethiopia to that in Fiji?
Make the answer very short. 1.16. What is the ratio of the Expenses (% of total expenses) of Subsidies and Transfers in Ethiopia to that in Fiji?
Your answer should be very brief. 1.51. What is the ratio of the Expenses (% of total expenses) in Other expenses in Ethiopia to that in Fiji?
Give a very brief answer. 36.26. What is the ratio of the Expenses (% of total expenses) of Compensation of employees in Ethiopia to that in Grenada?
Your response must be concise. 0.72. What is the ratio of the Expenses (% of total expenses) of Goods and services in Ethiopia to that in Grenada?
Your response must be concise. 1.93. What is the ratio of the Expenses (% of total expenses) of Subsidies and Transfers in Ethiopia to that in Grenada?
Give a very brief answer. 2.11. What is the ratio of the Expenses (% of total expenses) of Other expenses in Ethiopia to that in Grenada?
Make the answer very short. 8.31. What is the ratio of the Expenses (% of total expenses) in Compensation of employees in Fiji to that in Grenada?
Your answer should be very brief. 0.69. What is the ratio of the Expenses (% of total expenses) of Goods and services in Fiji to that in Grenada?
Your answer should be compact. 1.67. What is the ratio of the Expenses (% of total expenses) of Subsidies and Transfers in Fiji to that in Grenada?
Offer a very short reply. 1.39. What is the ratio of the Expenses (% of total expenses) of Other expenses in Fiji to that in Grenada?
Provide a succinct answer. 0.23. What is the difference between the highest and the second highest Expenses (% of total expenses) of Compensation of employees?
Give a very brief answer. 18.41. What is the difference between the highest and the second highest Expenses (% of total expenses) in Goods and services?
Give a very brief answer. 4.04. What is the difference between the highest and the second highest Expenses (% of total expenses) of Subsidies and Transfers?
Give a very brief answer. 31.36. What is the difference between the highest and the second highest Expenses (% of total expenses) of Other expenses?
Give a very brief answer. 6.68. What is the difference between the highest and the lowest Expenses (% of total expenses) in Compensation of employees?
Make the answer very short. 57.54. What is the difference between the highest and the lowest Expenses (% of total expenses) in Goods and services?
Your answer should be compact. 25.43. What is the difference between the highest and the lowest Expenses (% of total expenses) of Subsidies and Transfers?
Offer a terse response. 59.32. What is the difference between the highest and the lowest Expenses (% of total expenses) in Other expenses?
Give a very brief answer. 11.59. 